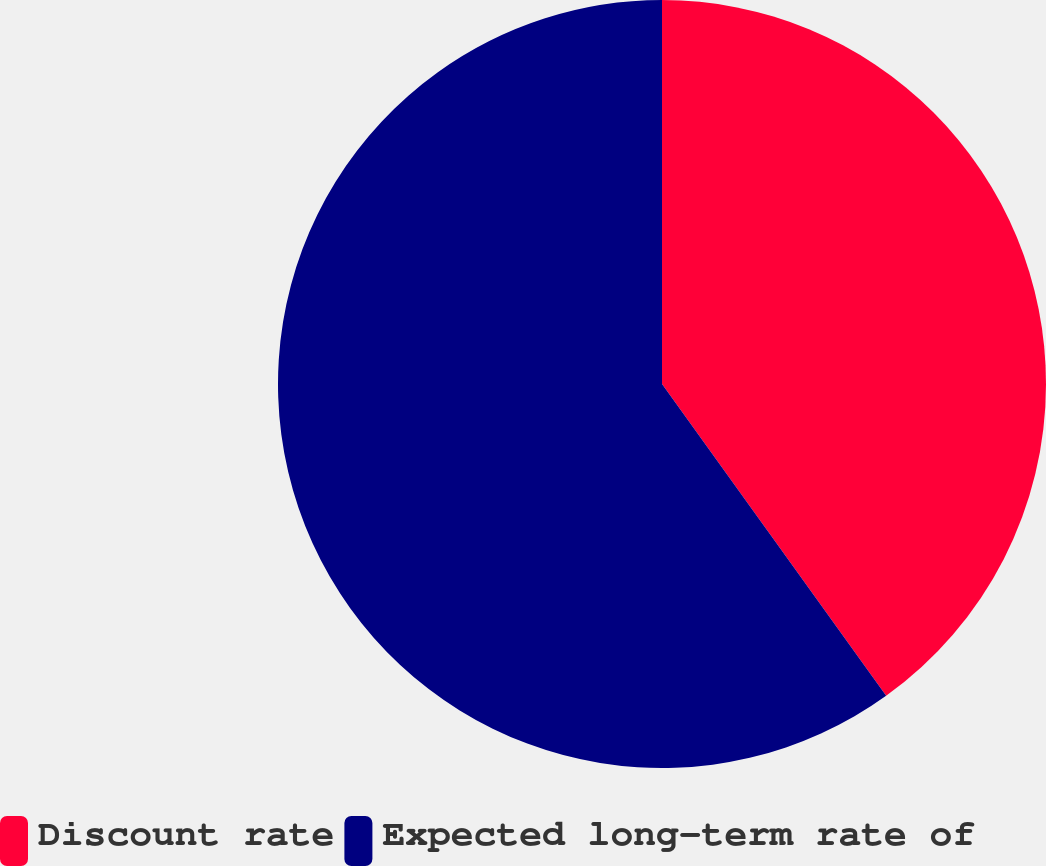<chart> <loc_0><loc_0><loc_500><loc_500><pie_chart><fcel>Discount rate<fcel>Expected long-term rate of<nl><fcel>40.08%<fcel>59.92%<nl></chart> 